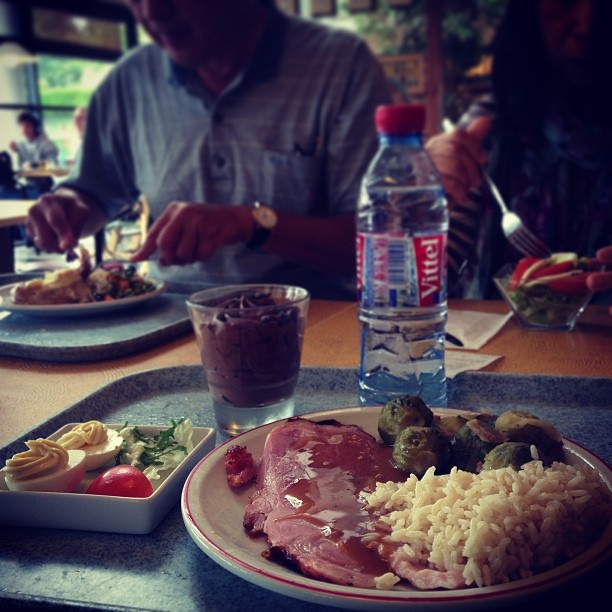Describe the objects in this image and their specific colors. I can see dining table in navy, black, gray, and maroon tones, people in navy, gray, and purple tones, people in navy, black, and purple tones, bottle in navy, gray, and purple tones, and bowl in navy, gray, maroon, and black tones in this image. 